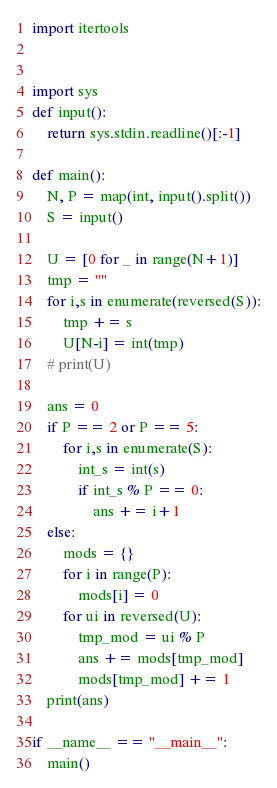Convert code to text. <code><loc_0><loc_0><loc_500><loc_500><_Python_>import itertools


import sys
def input():
    return sys.stdin.readline()[:-1]

def main():
    N, P = map(int, input().split())
    S = input()
    
    U = [0 for _ in range(N+1)]
    tmp = ""
    for i,s in enumerate(reversed(S)):
        tmp += s
        U[N-i] = int(tmp)
    # print(U)

    ans = 0
    if P == 2 or P == 5:
        for i,s in enumerate(S):
            int_s = int(s)
            if int_s % P == 0:
                ans += i+1
    else:
        mods = {}
        for i in range(P):
            mods[i] = 0
        for ui in reversed(U):
            tmp_mod = ui % P
            ans += mods[tmp_mod]
            mods[tmp_mod] += 1
    print(ans)

if __name__ == "__main__":
    main() </code> 